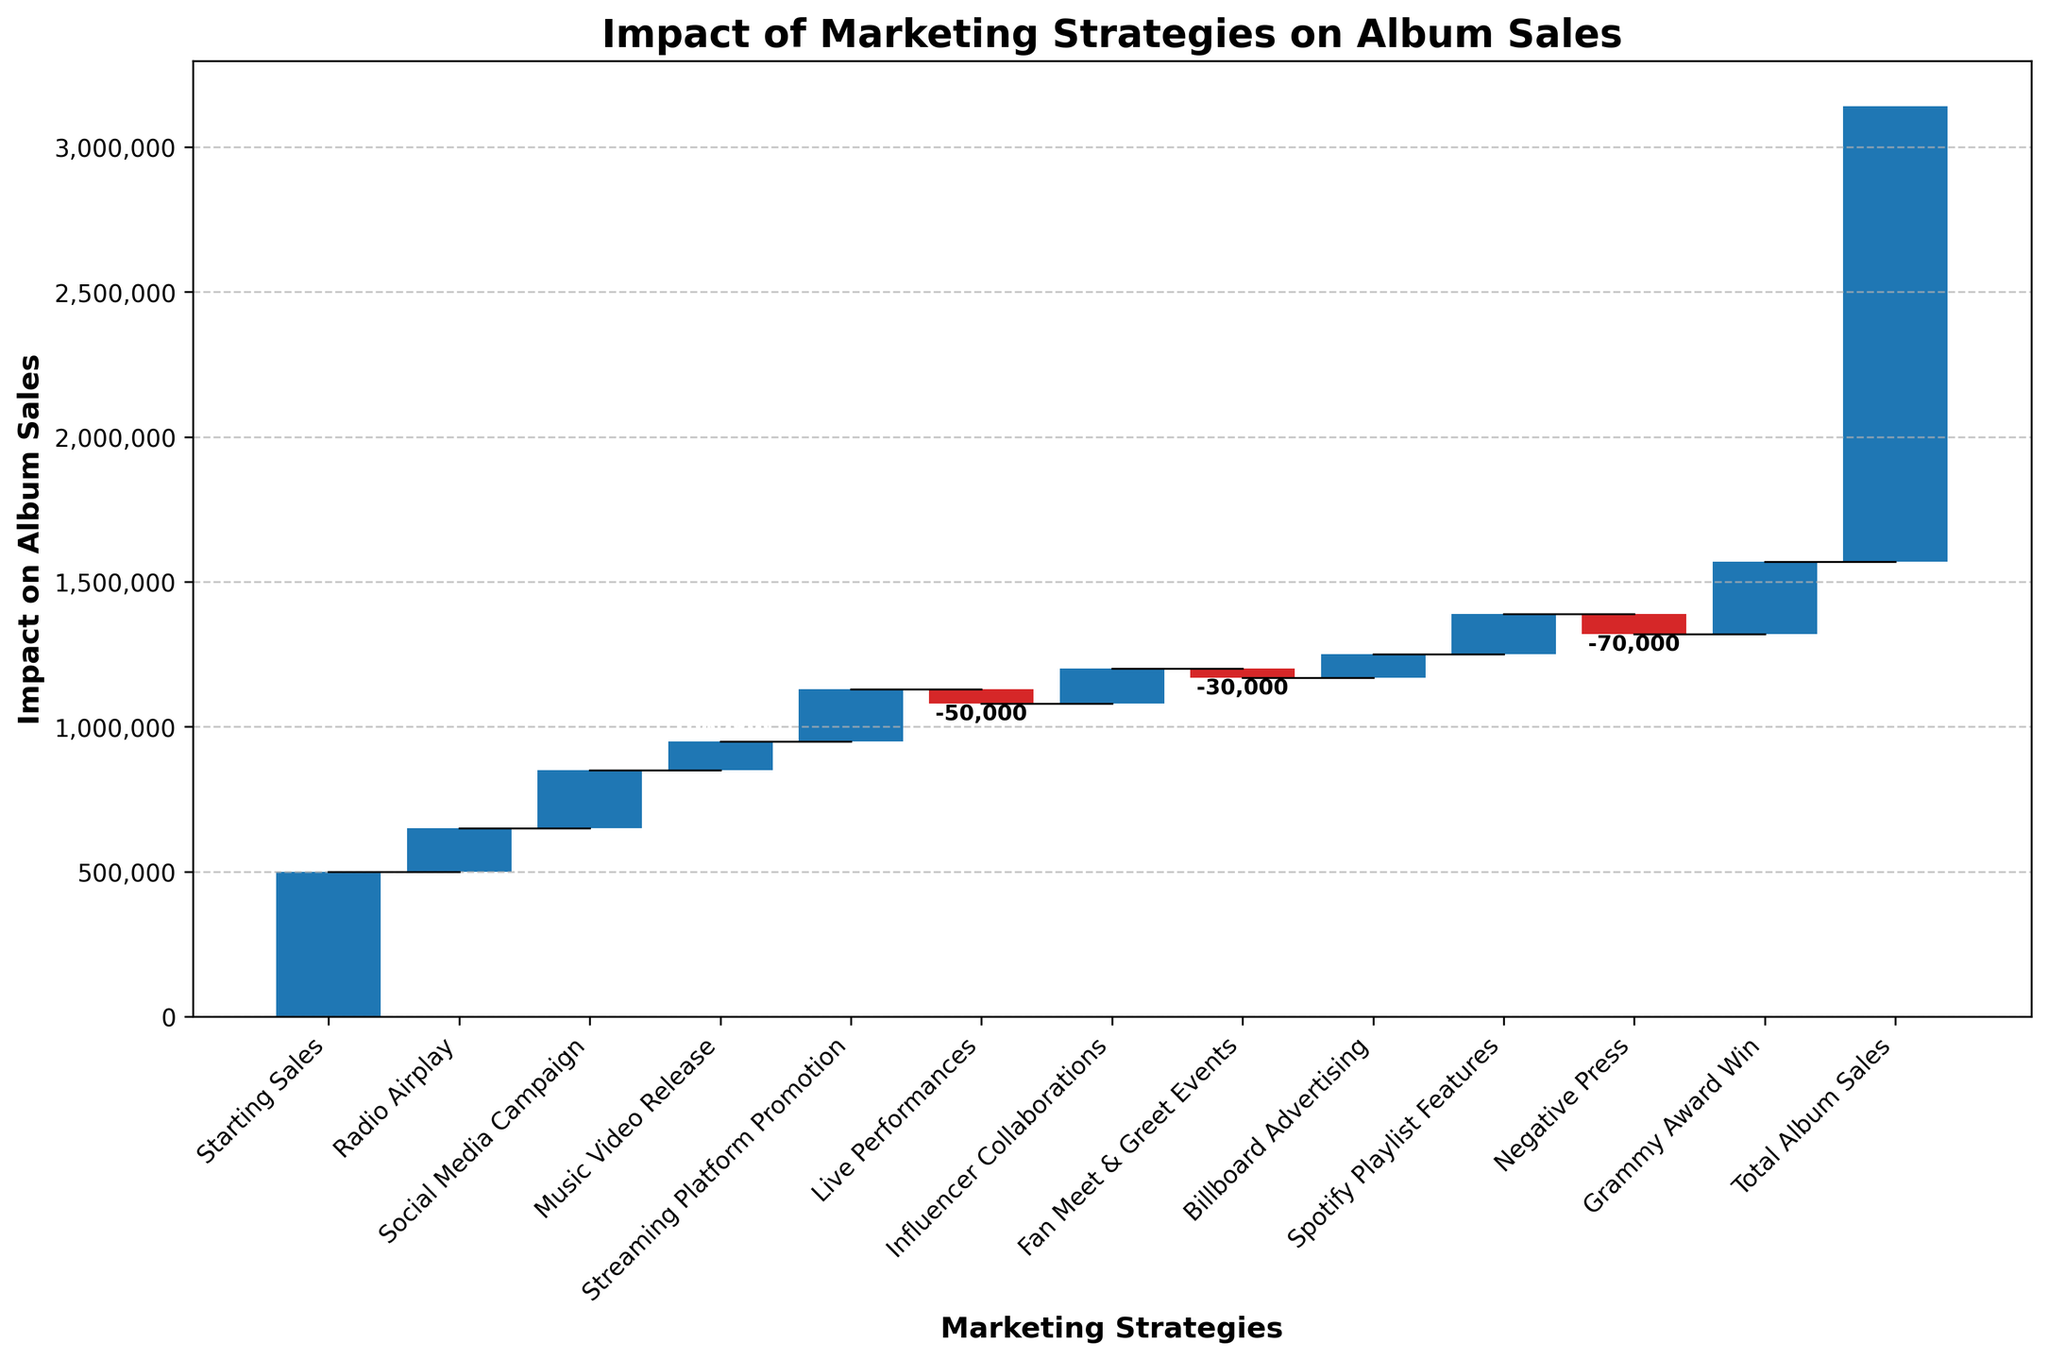What is the title of the chart? The title of the chart is displayed at the top of the figure and summarizes the content of the chart. It reads "Impact of Marketing Strategies on Album Sales."
Answer: Impact of Marketing Strategies on Album Sales Which marketing strategy had the highest positive impact on album sales? Look for the bar with the highest positive value (longest bar above the baseline). It corresponds to the "Grammy Award Win" category.
Answer: Grammy Award Win What is the total impact of negative events on album sales? Identify and sum the values of bars that go below the baseline, which represent the negative impacts: Live Performances (-50,000), Fan Meet & Greet Events (-30,000), Negative Press (-70,000). The sum is -50,000 + (-30,000) + (-70,000) = -150,000.
Answer: -150,000 What is the overall increase in album sales from all positive marketing strategies, excluding negative events? Sum the values of all positive impact bars: Radio Airplay (150,000), Social Media Campaign (200,000), Music Video Release (100,000), Streaming Platform Promotion (180,000), Influencer Collaborations (120,000), Billboard Advertising (80,000), Spotify Playlist Features (140,000), Grammy Award Win (250,000). Total positive impact = 150,000 + 200,000 + 100,000 + 180,000 + 120,000 + 80,000 + 140,000 + 250,000 = 1,220,000.
Answer: 1,220,000 How much did Live Performances decrease album sales? Locate the "Live Performances" category and note the value, which is a negative impact. The value is -50,000.
Answer: -50,000 Which marketing strategy added the least positive impact to album sales? Identify the positive values and find the smallest one: Radio Airplay (150,000), Social Media Campaign (200,000), Music Video Release (100,000), Streaming Platform Promotion (180,000), Influencer Collaborations (120,000), Billboard Advertising (80,000), Spotify Playlist Features (140,000), Grammy Award Win (250,000). The smallest positive value is from Billboard Advertising (80,000).
Answer: Billboard Advertising What was the cumulative impact on album sales after the addition of Streaming Platform Promotion? Sum the starting sales with the impacts up to and including Streaming Platform Promotion: Starting Sales (500,000) + Radio Airplay (150,000) + Social Media Campaign (200,000) + Music Video Release (100,000) + Streaming Platform Promotion (180,000) = 1,130,000.
Answer: 1,130,000 How did Fan Meet & Greet Events affect the cumulative impact on album sales? Fan Meet & Greet Events had a negative impact. The cumulative impact before this event was 1,130,000, and the value of the event was -30,000. Subtract this from the cumulative impact: 1,130,000 - 30,000 = 1,100,000.
Answer: Decreased by 30,000 What was the final total impact on album sales? Reference the total value displayed at the end of the chart. It states the total result after all cumulative impacts. This is labeled as "Total Album Sales" with a value of 1,570,000.
Answer: 1,570,000 Which category had the lowest impact on album sales regardless of it being positive or negative? Identify the category with the smallest absolute value: Fan Meet & Greet Events (-30,000) has the lowest absolute value of impact.
Answer: Fan Meet & Greet Events 